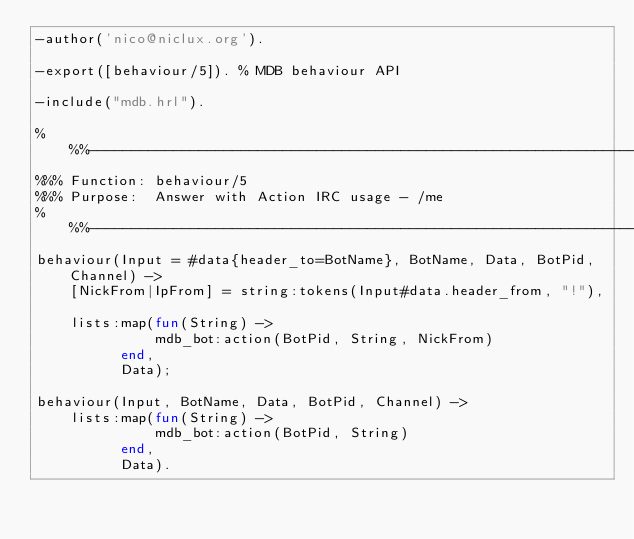<code> <loc_0><loc_0><loc_500><loc_500><_Erlang_>-author('nico@niclux.org').

-export([behaviour/5]). % MDB behaviour API

-include("mdb.hrl").

%%%----------------------------------------------------------------------
%%% Function: behaviour/5
%%% Purpose:  Answer with Action IRC usage - /me
%%%----------------------------------------------------------------------
behaviour(Input = #data{header_to=BotName}, BotName, Data, BotPid, Channel) ->
    [NickFrom|IpFrom] = string:tokens(Input#data.header_from, "!"),

    lists:map(fun(String) ->
		      mdb_bot:action(BotPid, String, NickFrom)
	      end,
	      Data);

behaviour(Input, BotName, Data, BotPid, Channel) ->
    lists:map(fun(String) ->
		      mdb_bot:action(BotPid, String)
	      end,
	      Data).

</code> 